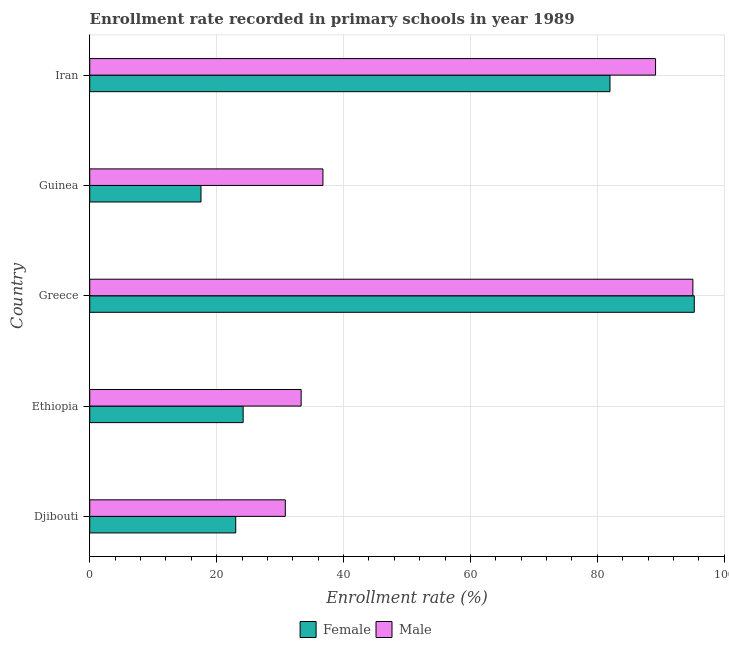Are the number of bars on each tick of the Y-axis equal?
Offer a terse response. Yes. How many bars are there on the 4th tick from the bottom?
Ensure brevity in your answer.  2. What is the label of the 4th group of bars from the top?
Make the answer very short. Ethiopia. In how many cases, is the number of bars for a given country not equal to the number of legend labels?
Give a very brief answer. 0. What is the enrollment rate of female students in Djibouti?
Give a very brief answer. 23.01. Across all countries, what is the maximum enrollment rate of male students?
Ensure brevity in your answer.  95.06. Across all countries, what is the minimum enrollment rate of male students?
Provide a short and direct response. 30.83. In which country was the enrollment rate of male students minimum?
Give a very brief answer. Djibouti. What is the total enrollment rate of female students in the graph?
Ensure brevity in your answer.  242.01. What is the difference between the enrollment rate of male students in Greece and that in Iran?
Your response must be concise. 5.88. What is the difference between the enrollment rate of female students in Guinea and the enrollment rate of male students in Djibouti?
Offer a terse response. -13.29. What is the average enrollment rate of female students per country?
Offer a terse response. 48.4. What is the difference between the enrollment rate of male students and enrollment rate of female students in Iran?
Your answer should be compact. 7.18. In how many countries, is the enrollment rate of male students greater than 80 %?
Your response must be concise. 2. What is the ratio of the enrollment rate of female students in Ethiopia to that in Iran?
Keep it short and to the point. 0.29. Is the enrollment rate of female students in Ethiopia less than that in Guinea?
Ensure brevity in your answer.  No. What is the difference between the highest and the second highest enrollment rate of male students?
Keep it short and to the point. 5.88. What is the difference between the highest and the lowest enrollment rate of male students?
Ensure brevity in your answer.  64.24. In how many countries, is the enrollment rate of male students greater than the average enrollment rate of male students taken over all countries?
Ensure brevity in your answer.  2. Is the sum of the enrollment rate of male students in Ethiopia and Iran greater than the maximum enrollment rate of female students across all countries?
Give a very brief answer. Yes. What does the 1st bar from the bottom in Greece represents?
Keep it short and to the point. Female. How many bars are there?
Ensure brevity in your answer.  10. Are all the bars in the graph horizontal?
Offer a very short reply. Yes. How many countries are there in the graph?
Provide a succinct answer. 5. What is the difference between two consecutive major ticks on the X-axis?
Your answer should be compact. 20. Are the values on the major ticks of X-axis written in scientific E-notation?
Ensure brevity in your answer.  No. Does the graph contain any zero values?
Keep it short and to the point. No. Does the graph contain grids?
Give a very brief answer. Yes. What is the title of the graph?
Offer a very short reply. Enrollment rate recorded in primary schools in year 1989. What is the label or title of the X-axis?
Provide a short and direct response. Enrollment rate (%). What is the Enrollment rate (%) in Female in Djibouti?
Offer a very short reply. 23.01. What is the Enrollment rate (%) of Male in Djibouti?
Provide a short and direct response. 30.83. What is the Enrollment rate (%) of Female in Ethiopia?
Give a very brief answer. 24.18. What is the Enrollment rate (%) of Male in Ethiopia?
Provide a short and direct response. 33.32. What is the Enrollment rate (%) of Female in Greece?
Offer a very short reply. 95.28. What is the Enrollment rate (%) in Male in Greece?
Your answer should be very brief. 95.06. What is the Enrollment rate (%) in Female in Guinea?
Your answer should be compact. 17.54. What is the Enrollment rate (%) of Male in Guinea?
Offer a terse response. 36.76. What is the Enrollment rate (%) in Female in Iran?
Provide a succinct answer. 82. What is the Enrollment rate (%) in Male in Iran?
Make the answer very short. 89.18. Across all countries, what is the maximum Enrollment rate (%) of Female?
Your answer should be very brief. 95.28. Across all countries, what is the maximum Enrollment rate (%) in Male?
Your answer should be compact. 95.06. Across all countries, what is the minimum Enrollment rate (%) of Female?
Make the answer very short. 17.54. Across all countries, what is the minimum Enrollment rate (%) in Male?
Your answer should be compact. 30.83. What is the total Enrollment rate (%) in Female in the graph?
Your answer should be very brief. 242.01. What is the total Enrollment rate (%) of Male in the graph?
Keep it short and to the point. 285.15. What is the difference between the Enrollment rate (%) in Female in Djibouti and that in Ethiopia?
Give a very brief answer. -1.17. What is the difference between the Enrollment rate (%) in Male in Djibouti and that in Ethiopia?
Make the answer very short. -2.5. What is the difference between the Enrollment rate (%) in Female in Djibouti and that in Greece?
Your answer should be very brief. -72.27. What is the difference between the Enrollment rate (%) of Male in Djibouti and that in Greece?
Your answer should be compact. -64.24. What is the difference between the Enrollment rate (%) of Female in Djibouti and that in Guinea?
Provide a short and direct response. 5.48. What is the difference between the Enrollment rate (%) in Male in Djibouti and that in Guinea?
Your response must be concise. -5.93. What is the difference between the Enrollment rate (%) of Female in Djibouti and that in Iran?
Offer a terse response. -58.98. What is the difference between the Enrollment rate (%) in Male in Djibouti and that in Iran?
Offer a terse response. -58.36. What is the difference between the Enrollment rate (%) of Female in Ethiopia and that in Greece?
Ensure brevity in your answer.  -71.1. What is the difference between the Enrollment rate (%) of Male in Ethiopia and that in Greece?
Provide a short and direct response. -61.74. What is the difference between the Enrollment rate (%) in Female in Ethiopia and that in Guinea?
Ensure brevity in your answer.  6.64. What is the difference between the Enrollment rate (%) of Male in Ethiopia and that in Guinea?
Ensure brevity in your answer.  -3.44. What is the difference between the Enrollment rate (%) of Female in Ethiopia and that in Iran?
Make the answer very short. -57.82. What is the difference between the Enrollment rate (%) of Male in Ethiopia and that in Iran?
Give a very brief answer. -55.86. What is the difference between the Enrollment rate (%) of Female in Greece and that in Guinea?
Offer a very short reply. 77.74. What is the difference between the Enrollment rate (%) of Male in Greece and that in Guinea?
Your answer should be compact. 58.3. What is the difference between the Enrollment rate (%) in Female in Greece and that in Iran?
Keep it short and to the point. 13.28. What is the difference between the Enrollment rate (%) in Male in Greece and that in Iran?
Ensure brevity in your answer.  5.88. What is the difference between the Enrollment rate (%) of Female in Guinea and that in Iran?
Keep it short and to the point. -64.46. What is the difference between the Enrollment rate (%) of Male in Guinea and that in Iran?
Make the answer very short. -52.43. What is the difference between the Enrollment rate (%) in Female in Djibouti and the Enrollment rate (%) in Male in Ethiopia?
Offer a terse response. -10.31. What is the difference between the Enrollment rate (%) of Female in Djibouti and the Enrollment rate (%) of Male in Greece?
Provide a short and direct response. -72.05. What is the difference between the Enrollment rate (%) in Female in Djibouti and the Enrollment rate (%) in Male in Guinea?
Your response must be concise. -13.74. What is the difference between the Enrollment rate (%) of Female in Djibouti and the Enrollment rate (%) of Male in Iran?
Offer a very short reply. -66.17. What is the difference between the Enrollment rate (%) in Female in Ethiopia and the Enrollment rate (%) in Male in Greece?
Your response must be concise. -70.88. What is the difference between the Enrollment rate (%) of Female in Ethiopia and the Enrollment rate (%) of Male in Guinea?
Your answer should be compact. -12.58. What is the difference between the Enrollment rate (%) of Female in Ethiopia and the Enrollment rate (%) of Male in Iran?
Give a very brief answer. -65. What is the difference between the Enrollment rate (%) in Female in Greece and the Enrollment rate (%) in Male in Guinea?
Your response must be concise. 58.52. What is the difference between the Enrollment rate (%) in Female in Greece and the Enrollment rate (%) in Male in Iran?
Your answer should be very brief. 6.1. What is the difference between the Enrollment rate (%) of Female in Guinea and the Enrollment rate (%) of Male in Iran?
Give a very brief answer. -71.64. What is the average Enrollment rate (%) of Female per country?
Make the answer very short. 48.4. What is the average Enrollment rate (%) in Male per country?
Offer a very short reply. 57.03. What is the difference between the Enrollment rate (%) of Female and Enrollment rate (%) of Male in Djibouti?
Provide a succinct answer. -7.81. What is the difference between the Enrollment rate (%) in Female and Enrollment rate (%) in Male in Ethiopia?
Make the answer very short. -9.14. What is the difference between the Enrollment rate (%) of Female and Enrollment rate (%) of Male in Greece?
Your answer should be compact. 0.22. What is the difference between the Enrollment rate (%) in Female and Enrollment rate (%) in Male in Guinea?
Your response must be concise. -19.22. What is the difference between the Enrollment rate (%) in Female and Enrollment rate (%) in Male in Iran?
Your response must be concise. -7.18. What is the ratio of the Enrollment rate (%) of Female in Djibouti to that in Ethiopia?
Keep it short and to the point. 0.95. What is the ratio of the Enrollment rate (%) of Male in Djibouti to that in Ethiopia?
Your answer should be compact. 0.93. What is the ratio of the Enrollment rate (%) of Female in Djibouti to that in Greece?
Offer a terse response. 0.24. What is the ratio of the Enrollment rate (%) of Male in Djibouti to that in Greece?
Make the answer very short. 0.32. What is the ratio of the Enrollment rate (%) in Female in Djibouti to that in Guinea?
Keep it short and to the point. 1.31. What is the ratio of the Enrollment rate (%) of Male in Djibouti to that in Guinea?
Ensure brevity in your answer.  0.84. What is the ratio of the Enrollment rate (%) of Female in Djibouti to that in Iran?
Your response must be concise. 0.28. What is the ratio of the Enrollment rate (%) of Male in Djibouti to that in Iran?
Your answer should be compact. 0.35. What is the ratio of the Enrollment rate (%) in Female in Ethiopia to that in Greece?
Offer a very short reply. 0.25. What is the ratio of the Enrollment rate (%) in Male in Ethiopia to that in Greece?
Keep it short and to the point. 0.35. What is the ratio of the Enrollment rate (%) in Female in Ethiopia to that in Guinea?
Offer a very short reply. 1.38. What is the ratio of the Enrollment rate (%) in Male in Ethiopia to that in Guinea?
Offer a very short reply. 0.91. What is the ratio of the Enrollment rate (%) of Female in Ethiopia to that in Iran?
Provide a short and direct response. 0.29. What is the ratio of the Enrollment rate (%) in Male in Ethiopia to that in Iran?
Keep it short and to the point. 0.37. What is the ratio of the Enrollment rate (%) in Female in Greece to that in Guinea?
Make the answer very short. 5.43. What is the ratio of the Enrollment rate (%) of Male in Greece to that in Guinea?
Your answer should be very brief. 2.59. What is the ratio of the Enrollment rate (%) in Female in Greece to that in Iran?
Give a very brief answer. 1.16. What is the ratio of the Enrollment rate (%) of Male in Greece to that in Iran?
Offer a very short reply. 1.07. What is the ratio of the Enrollment rate (%) in Female in Guinea to that in Iran?
Your answer should be very brief. 0.21. What is the ratio of the Enrollment rate (%) in Male in Guinea to that in Iran?
Ensure brevity in your answer.  0.41. What is the difference between the highest and the second highest Enrollment rate (%) of Female?
Give a very brief answer. 13.28. What is the difference between the highest and the second highest Enrollment rate (%) in Male?
Offer a very short reply. 5.88. What is the difference between the highest and the lowest Enrollment rate (%) in Female?
Offer a very short reply. 77.74. What is the difference between the highest and the lowest Enrollment rate (%) of Male?
Keep it short and to the point. 64.24. 